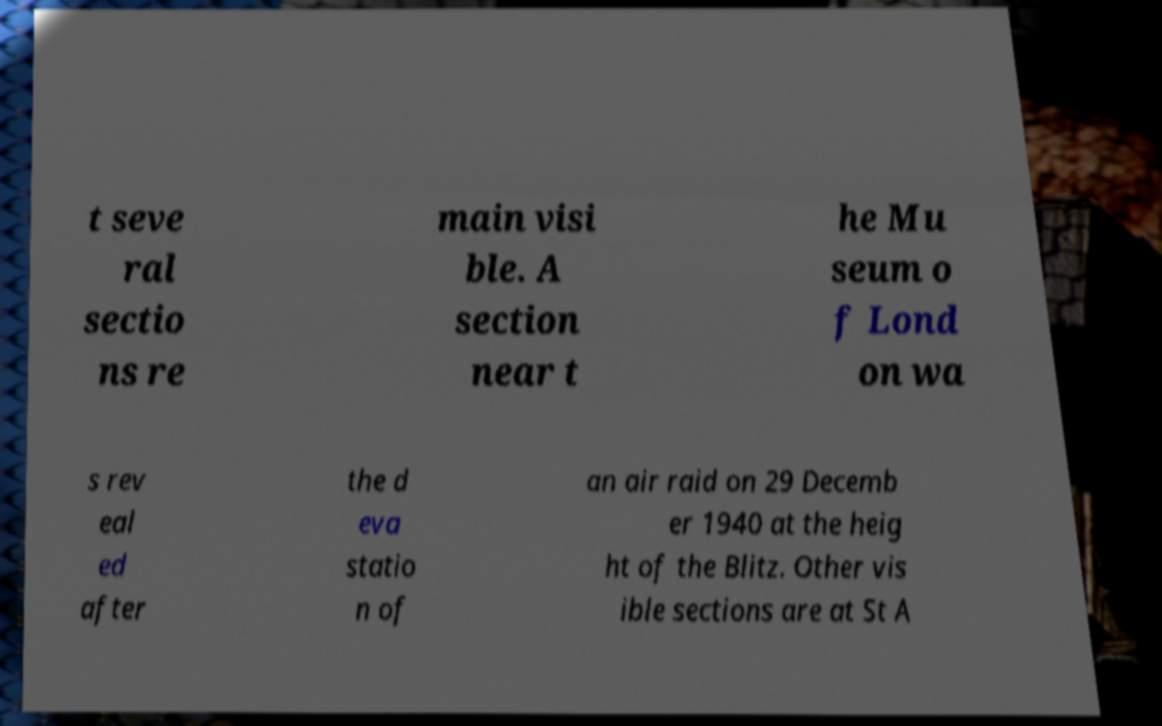Could you assist in decoding the text presented in this image and type it out clearly? t seve ral sectio ns re main visi ble. A section near t he Mu seum o f Lond on wa s rev eal ed after the d eva statio n of an air raid on 29 Decemb er 1940 at the heig ht of the Blitz. Other vis ible sections are at St A 